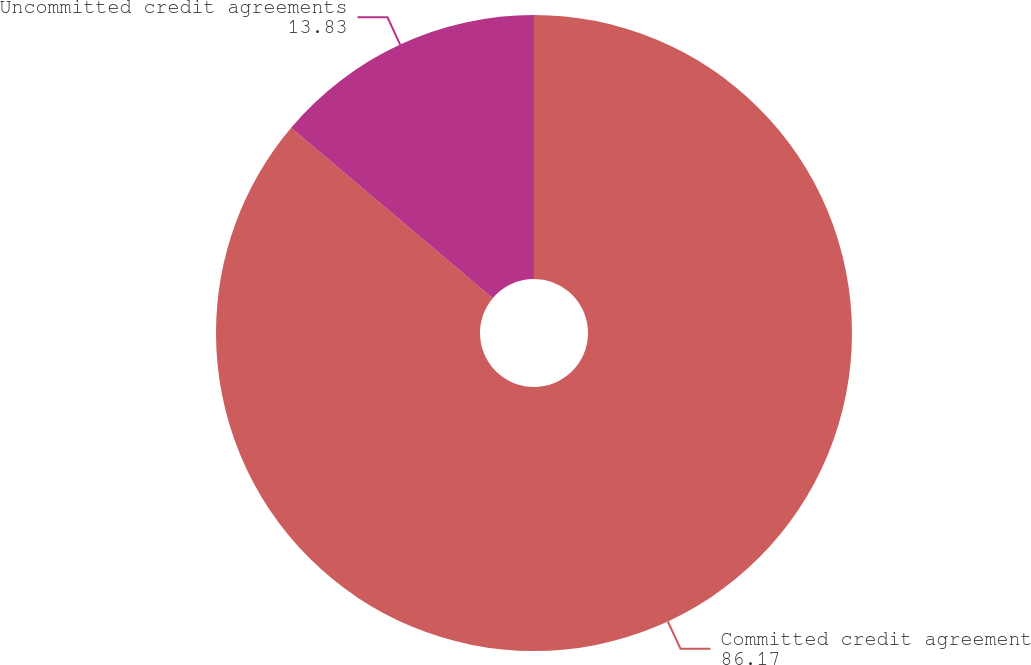Convert chart. <chart><loc_0><loc_0><loc_500><loc_500><pie_chart><fcel>Committed credit agreement<fcel>Uncommitted credit agreements<nl><fcel>86.17%<fcel>13.83%<nl></chart> 